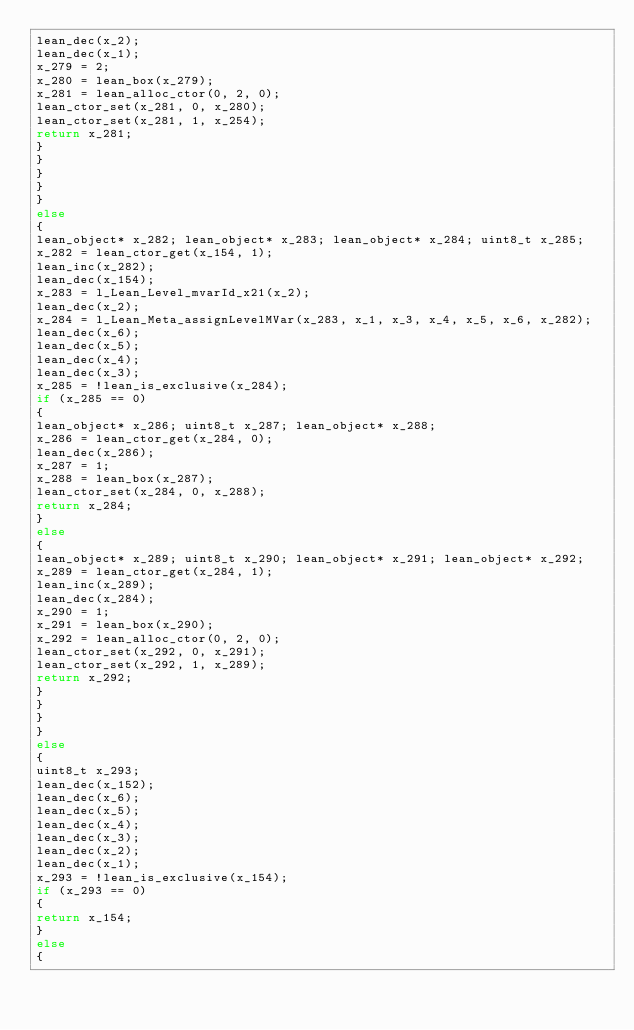Convert code to text. <code><loc_0><loc_0><loc_500><loc_500><_C_>lean_dec(x_2);
lean_dec(x_1);
x_279 = 2;
x_280 = lean_box(x_279);
x_281 = lean_alloc_ctor(0, 2, 0);
lean_ctor_set(x_281, 0, x_280);
lean_ctor_set(x_281, 1, x_254);
return x_281;
}
}
}
}
}
else
{
lean_object* x_282; lean_object* x_283; lean_object* x_284; uint8_t x_285; 
x_282 = lean_ctor_get(x_154, 1);
lean_inc(x_282);
lean_dec(x_154);
x_283 = l_Lean_Level_mvarId_x21(x_2);
lean_dec(x_2);
x_284 = l_Lean_Meta_assignLevelMVar(x_283, x_1, x_3, x_4, x_5, x_6, x_282);
lean_dec(x_6);
lean_dec(x_5);
lean_dec(x_4);
lean_dec(x_3);
x_285 = !lean_is_exclusive(x_284);
if (x_285 == 0)
{
lean_object* x_286; uint8_t x_287; lean_object* x_288; 
x_286 = lean_ctor_get(x_284, 0);
lean_dec(x_286);
x_287 = 1;
x_288 = lean_box(x_287);
lean_ctor_set(x_284, 0, x_288);
return x_284;
}
else
{
lean_object* x_289; uint8_t x_290; lean_object* x_291; lean_object* x_292; 
x_289 = lean_ctor_get(x_284, 1);
lean_inc(x_289);
lean_dec(x_284);
x_290 = 1;
x_291 = lean_box(x_290);
x_292 = lean_alloc_ctor(0, 2, 0);
lean_ctor_set(x_292, 0, x_291);
lean_ctor_set(x_292, 1, x_289);
return x_292;
}
}
}
}
else
{
uint8_t x_293; 
lean_dec(x_152);
lean_dec(x_6);
lean_dec(x_5);
lean_dec(x_4);
lean_dec(x_3);
lean_dec(x_2);
lean_dec(x_1);
x_293 = !lean_is_exclusive(x_154);
if (x_293 == 0)
{
return x_154;
}
else
{</code> 